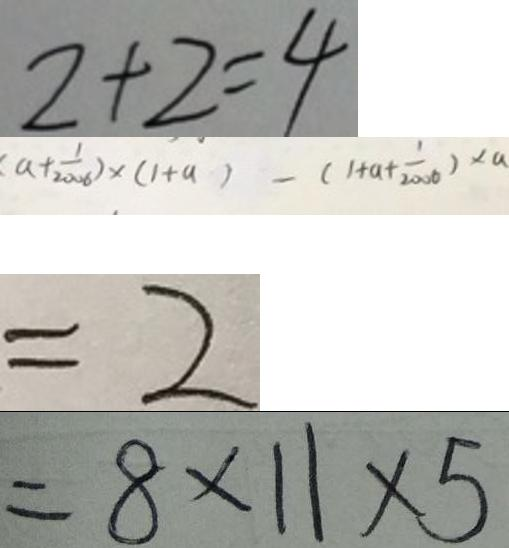<formula> <loc_0><loc_0><loc_500><loc_500>2 + 2 = 4 
 ( a + \frac { 1 } { 2 0 0 6 } ) \times ( 1 + a ) - ( 1 + a + \frac { 1 } { 2 0 0 6 } ) \times a 
 = 2 
 = 8 \times 1 1 \times 5</formula> 